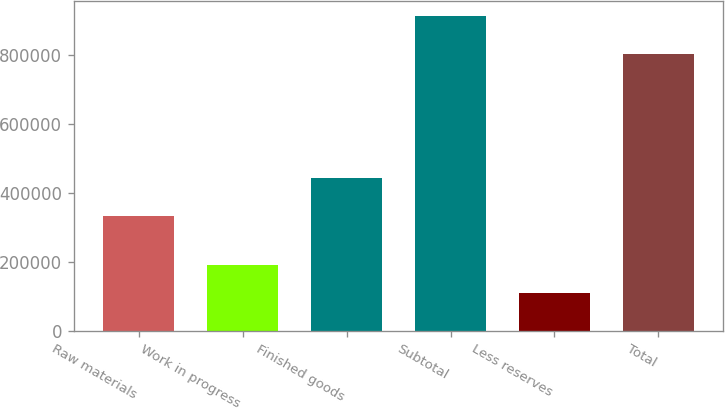<chart> <loc_0><loc_0><loc_500><loc_500><bar_chart><fcel>Raw materials<fcel>Work in progress<fcel>Finished goods<fcel>Subtotal<fcel>Less reserves<fcel>Total<nl><fcel>333551<fcel>189602<fcel>443032<fcel>912207<fcel>109312<fcel>802895<nl></chart> 